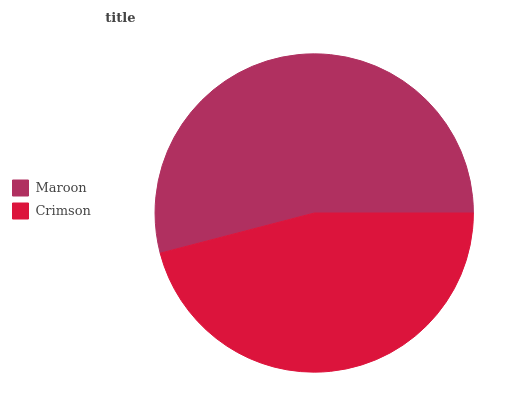Is Crimson the minimum?
Answer yes or no. Yes. Is Maroon the maximum?
Answer yes or no. Yes. Is Crimson the maximum?
Answer yes or no. No. Is Maroon greater than Crimson?
Answer yes or no. Yes. Is Crimson less than Maroon?
Answer yes or no. Yes. Is Crimson greater than Maroon?
Answer yes or no. No. Is Maroon less than Crimson?
Answer yes or no. No. Is Maroon the high median?
Answer yes or no. Yes. Is Crimson the low median?
Answer yes or no. Yes. Is Crimson the high median?
Answer yes or no. No. Is Maroon the low median?
Answer yes or no. No. 